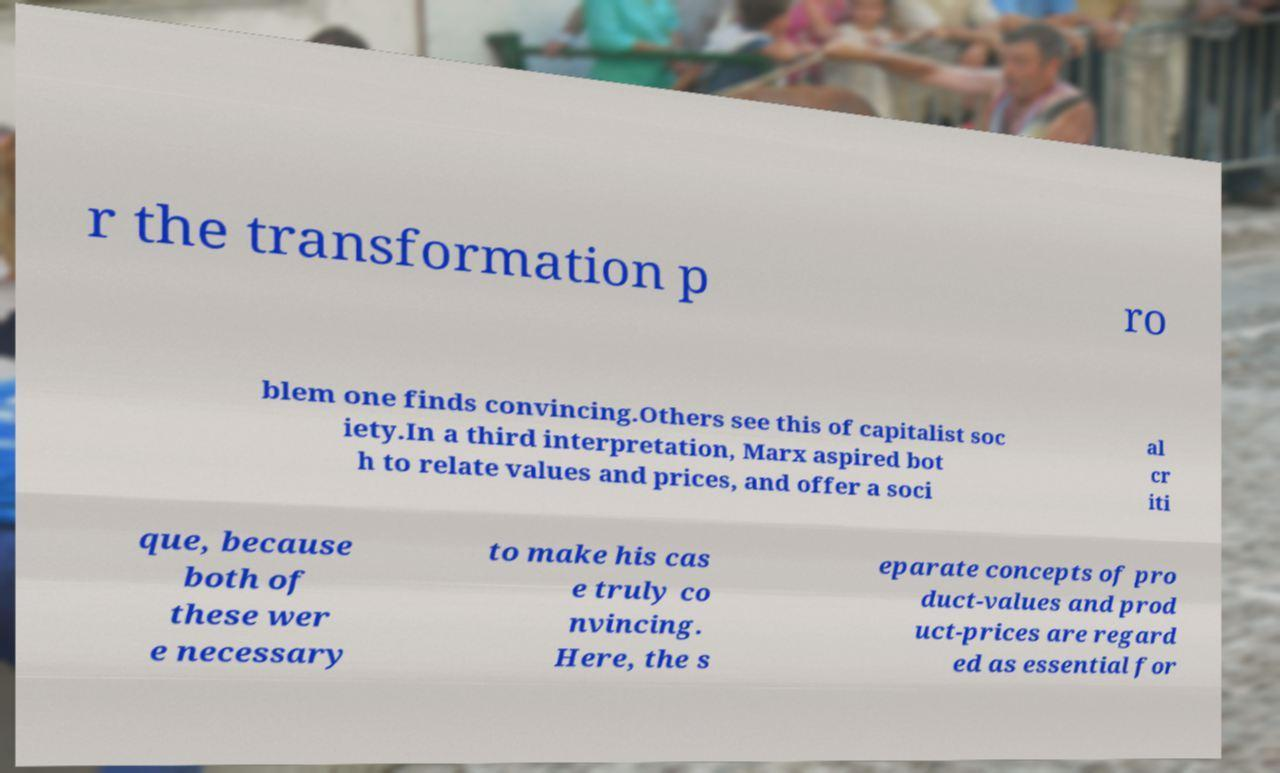There's text embedded in this image that I need extracted. Can you transcribe it verbatim? r the transformation p ro blem one finds convincing.Others see this of capitalist soc iety.In a third interpretation, Marx aspired bot h to relate values and prices, and offer a soci al cr iti que, because both of these wer e necessary to make his cas e truly co nvincing. Here, the s eparate concepts of pro duct-values and prod uct-prices are regard ed as essential for 